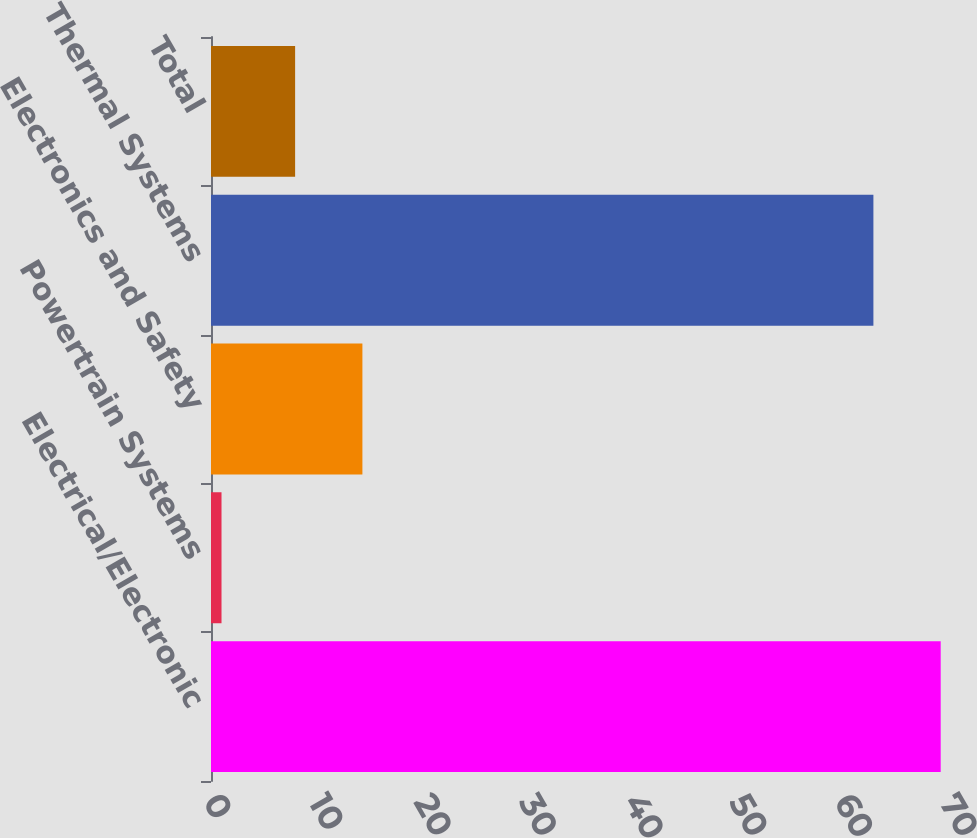Convert chart to OTSL. <chart><loc_0><loc_0><loc_500><loc_500><bar_chart><fcel>Electrical/Electronic<fcel>Powertrain Systems<fcel>Electronics and Safety<fcel>Thermal Systems<fcel>Total<nl><fcel>69.4<fcel>1<fcel>14.4<fcel>63<fcel>8<nl></chart> 